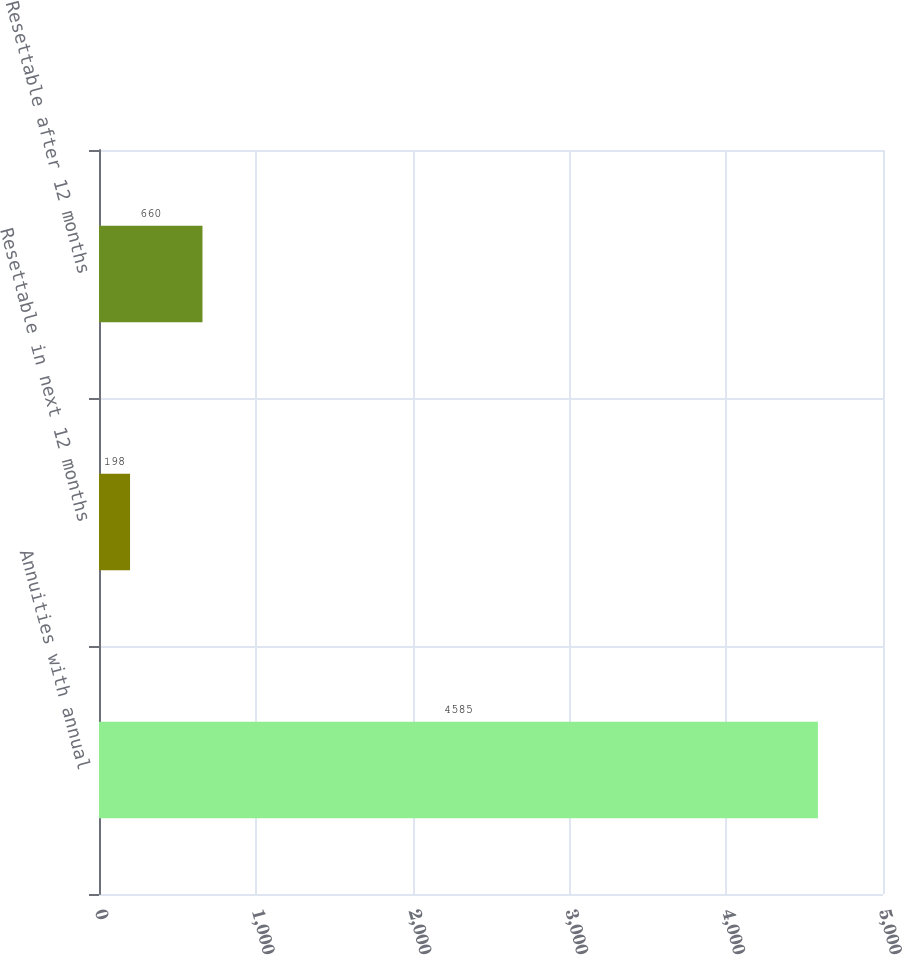Convert chart. <chart><loc_0><loc_0><loc_500><loc_500><bar_chart><fcel>Annuities with annual<fcel>Resettable in next 12 months<fcel>Resettable after 12 months<nl><fcel>4585<fcel>198<fcel>660<nl></chart> 